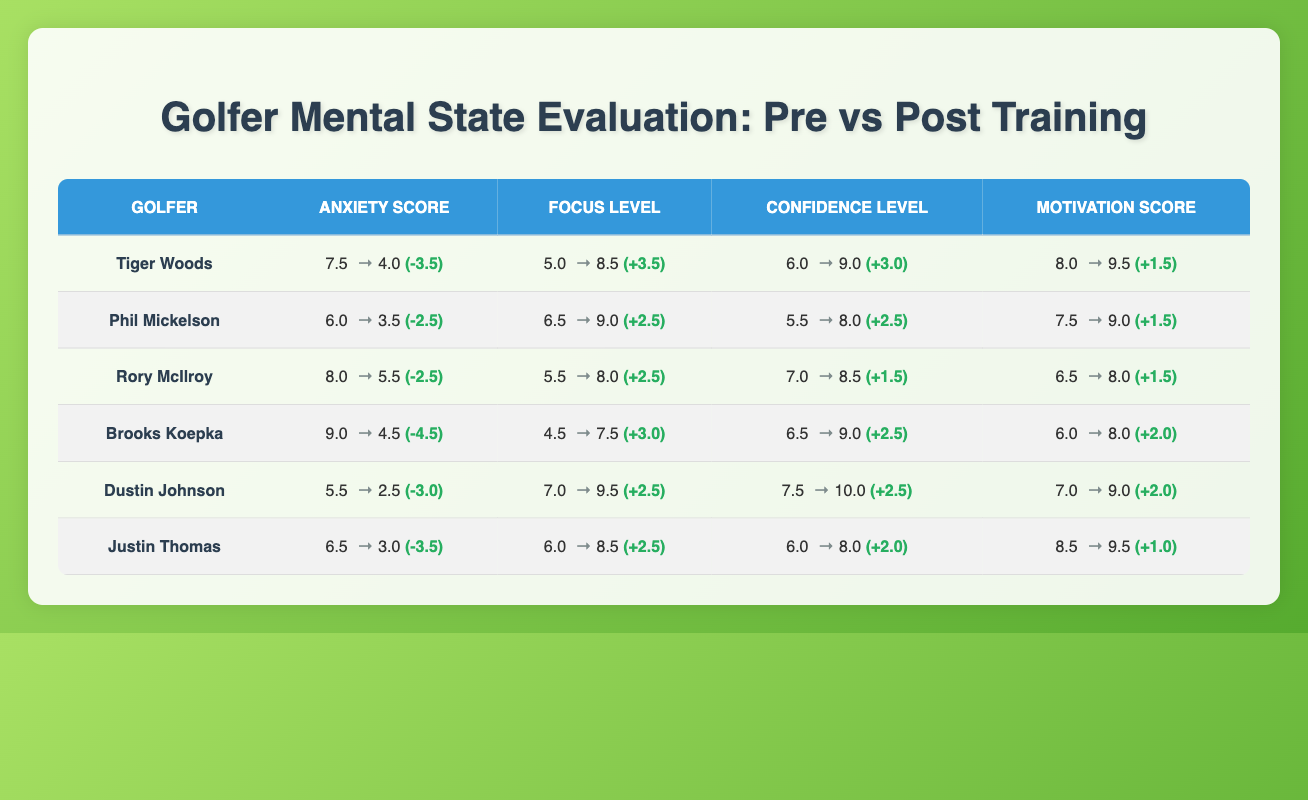What is Tiger Woods' post-training anxiety score? The table shows that Tiger Woods' post-training anxiety score is listed under the Anxiety Score column where it indicates 4.0.
Answer: 4.0 What was Phil Mickelson's pre-training motivation score? Phil Mickelson's pre-training motivation score is found in the Motivation Score column, displaying a value of 7.5.
Answer: 7.5 Which golfer had the highest pre-training anxiety score? The highest pre-training anxiety score can be identified by comparing the Anxiety Score column. Brooks Koepka has the highest pre-training anxiety score of 9.0.
Answer: Brooks Koepka What is the change in confidence level for Rory McIlroy after training? To find the change in confidence level for Rory McIlroy, subtract the post-training confidence level (8.5) from the pre-training level (7.0), resulting in an increase of 1.5.
Answer: +1.5 Did any golfer show an increase in anxiety score after training? By examining the Anxiety Score column for post-training values, none of the golfers show an increase; all scores are lower post-training than pre-training.
Answer: No What is the average post-training focus level of all golfers? To determine the average post-training focus level, sum the post-training focus levels (8.5 + 9.0 + 8.0 + 7.5 + 9.5 + 8.5 = 51.0) and divide by the number of golfers (6), resulting in an average of 8.5.
Answer: 8.5 Which golfer improved their motivation score the most? To find out who improved their motivation score the most, calculate the differences between post and pre-scores for all golfers. Dustin Johnson has an improvement of 2.0 (9.0 - 7.0), which is less than other golfers. However, Phil Mickelson and Rory McIlroy also improved by 1.5. Overall, the winner demonstrating the highest improvement is Dustin Johnson at 2.0.
Answer: Dustin Johnson What is the total change in anxiety from pre-training to post-training for Justin Thomas? The total change in anxiety for Justin Thomas is calculated by subtracting the post-training anxiety score (3.0) from the pre-training score (6.5), resulting in a change of 3.5.
Answer: -3.5 Which golfer had the lowest pre-training confidence level? By reviewing the Confidence Level column, Justin Thomas had the lowest pre-training confidence level at 6.0.
Answer: Justin Thomas Is there a golfer who had a post-training motivation score of 10.0? Inspecting the Motivation Score column, Dustin Johnson is the only golfer who achieved a post-training motivation score of 10.0.
Answer: Yes Who had the least improvement in motivation score after training? To determine the least improvement, calculate the changes for each golfer. Justin Thomas has an improvement of 1.0 in motivation score, which is the lowest among all.
Answer: Justin Thomas 